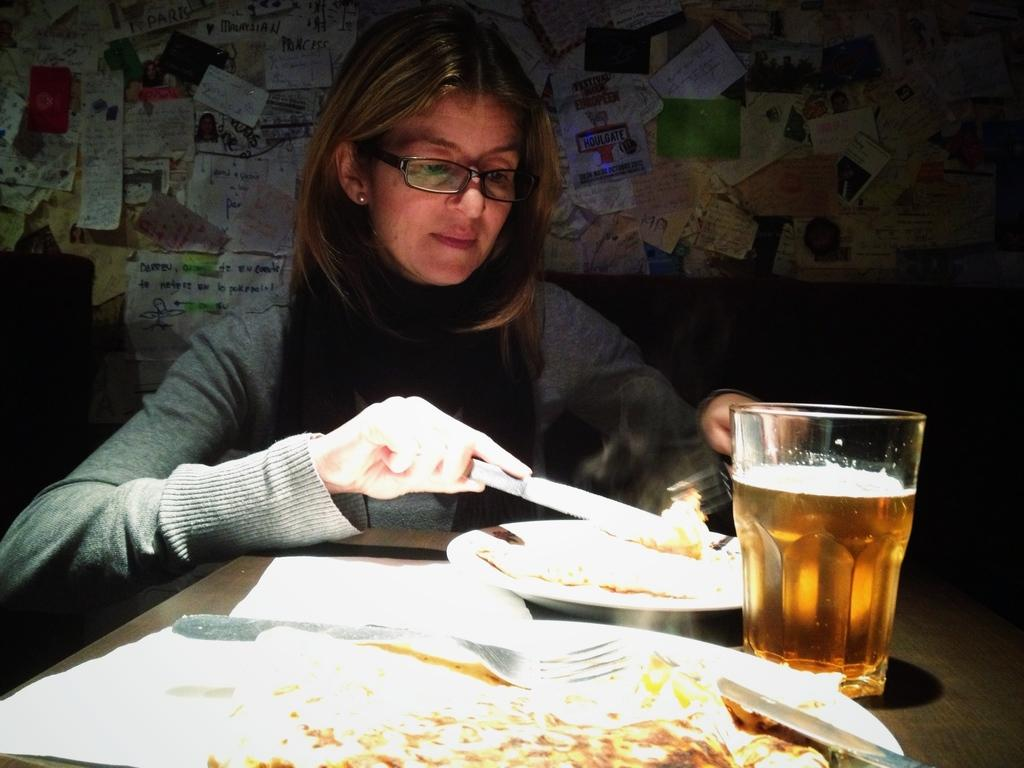Who is in the image? There is a woman in the image. What is the woman wearing? The woman is wearing a grey t-shirt. Where is the woman located in the image? The woman is sitting in front of a table. What is on the table in the image? There is food, plates, a knife, a fork, and a wine glass on the table. What is on the wall behind the table? There are sticky notes on the wall behind the table. What type of cave can be seen in the background of the image? There is no cave present in the image; it features a woman sitting in front of a table with various objects. How does the cub interact with the food on the table? There is no cub present in the image; it only features a woman, a table, and various objects. 